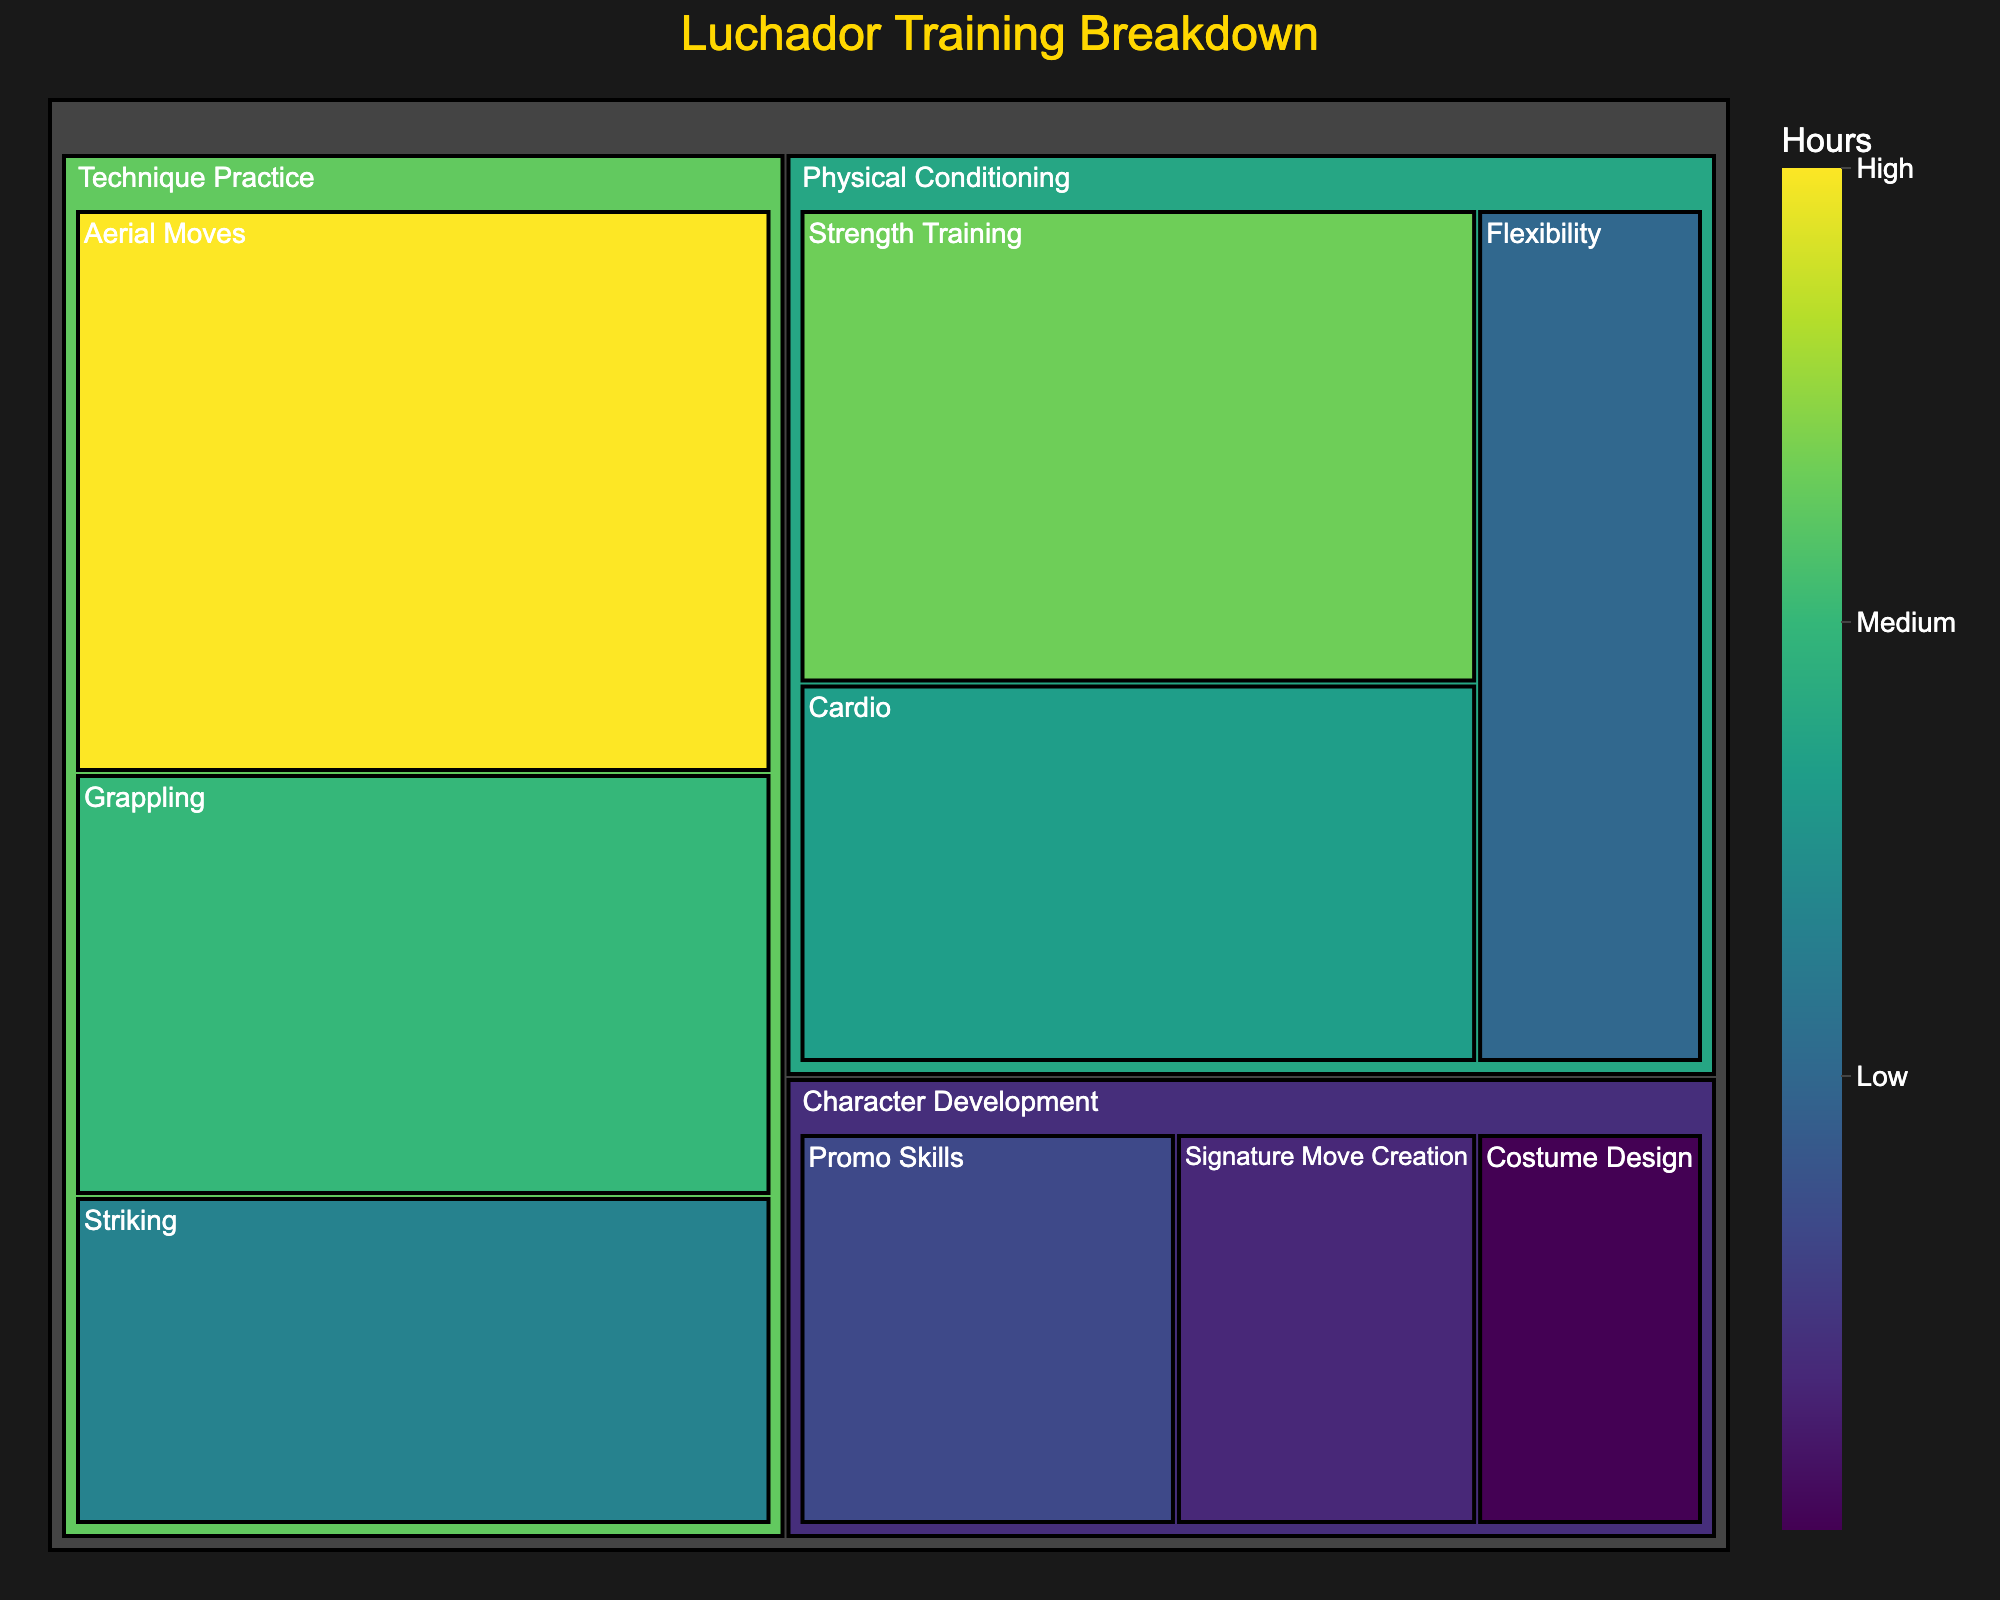What is the title of the treemap? The title is usually found at the top of the treemap and it summarizes the content being displayed.
Answer: Luchador Training Breakdown Which subcategory under Physical Conditioning has the highest training hours? To answer this, first identify the subcategories under Physical Conditioning and then compare their respective hours.
Answer: Strength Training How many total hours are spent on Technique Practice? Sum the hours for all subcategories under Technique Practice: Aerial Moves (12), Grappling (9), and Striking (7). 12 + 9 + 7 = 28
Answer: 28 Which subcategory under Character Development has the least training hours? Identify the subcategories under Character Development and compare their hours to find the lowest one.
Answer: Costume Design Is more time spent on Cardio or on Promo Skills? Compare the number of training hours for Cardio (8) to those for Promo Skills (5).
Answer: Cardio What are the subcategories under Physical Conditioning? List the subcategories grouped under the category Physical Conditioning.
Answer: Strength Training, Cardio, Flexibility What’s the total number of hours spent on Character Development? Sum the hours for all subcategories under Character Development: Promo Skills (5), Costume Design (3), and Signature Move Creation (4). 5 + 3 + 4 = 12
Answer: 12 Which category has the highest overall training hours? Calculate the total hours spent in each category and compare: Physical Conditioning (10+8+6), Technique Practice (12+9+7), Character Development (5+3+4).
Answer: Technique Practice What is the average number of hours spent on each subcategory under Technique Practice? Sum the hours for Technique Practice and divide by the number of subcategories: (12 + 9 + 7) / 3 = 28 / 3 = 9.33
Answer: 9.33 What is the largest single allocation of training hours? Identify the subcategory with the maximum hours across all categories.
Answer: Aerial Moves 